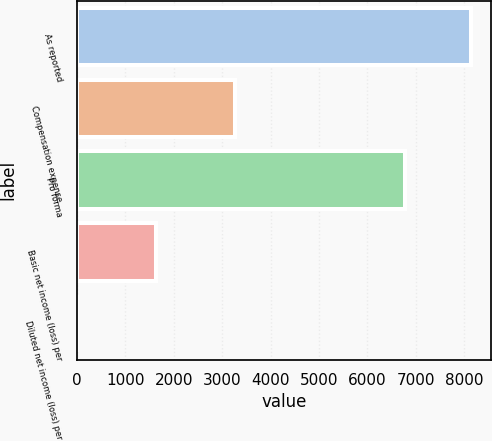Convert chart to OTSL. <chart><loc_0><loc_0><loc_500><loc_500><bar_chart><fcel>As reported<fcel>Compensation expense<fcel>Pro forma<fcel>Basic net income (loss) per<fcel>Diluted net income (loss) per<nl><fcel>8142<fcel>3256.91<fcel>6776<fcel>1628.55<fcel>0.19<nl></chart> 